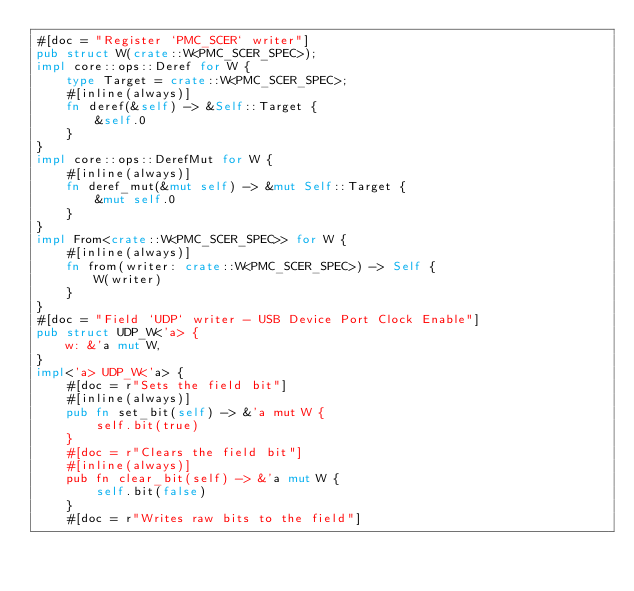Convert code to text. <code><loc_0><loc_0><loc_500><loc_500><_Rust_>#[doc = "Register `PMC_SCER` writer"]
pub struct W(crate::W<PMC_SCER_SPEC>);
impl core::ops::Deref for W {
    type Target = crate::W<PMC_SCER_SPEC>;
    #[inline(always)]
    fn deref(&self) -> &Self::Target {
        &self.0
    }
}
impl core::ops::DerefMut for W {
    #[inline(always)]
    fn deref_mut(&mut self) -> &mut Self::Target {
        &mut self.0
    }
}
impl From<crate::W<PMC_SCER_SPEC>> for W {
    #[inline(always)]
    fn from(writer: crate::W<PMC_SCER_SPEC>) -> Self {
        W(writer)
    }
}
#[doc = "Field `UDP` writer - USB Device Port Clock Enable"]
pub struct UDP_W<'a> {
    w: &'a mut W,
}
impl<'a> UDP_W<'a> {
    #[doc = r"Sets the field bit"]
    #[inline(always)]
    pub fn set_bit(self) -> &'a mut W {
        self.bit(true)
    }
    #[doc = r"Clears the field bit"]
    #[inline(always)]
    pub fn clear_bit(self) -> &'a mut W {
        self.bit(false)
    }
    #[doc = r"Writes raw bits to the field"]</code> 